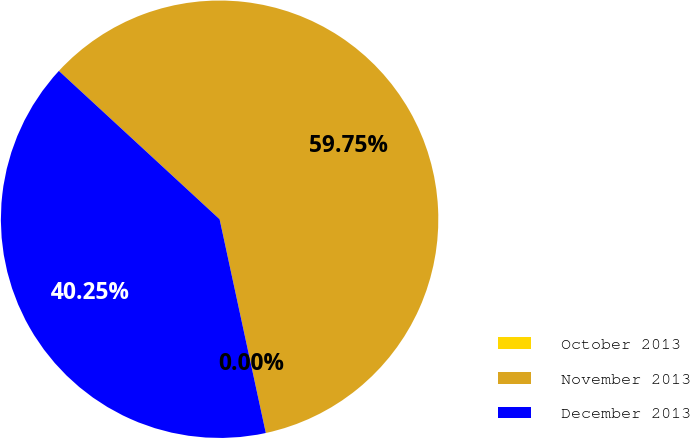Convert chart. <chart><loc_0><loc_0><loc_500><loc_500><pie_chart><fcel>October 2013<fcel>November 2013<fcel>December 2013<nl><fcel>0.0%<fcel>59.75%<fcel>40.25%<nl></chart> 